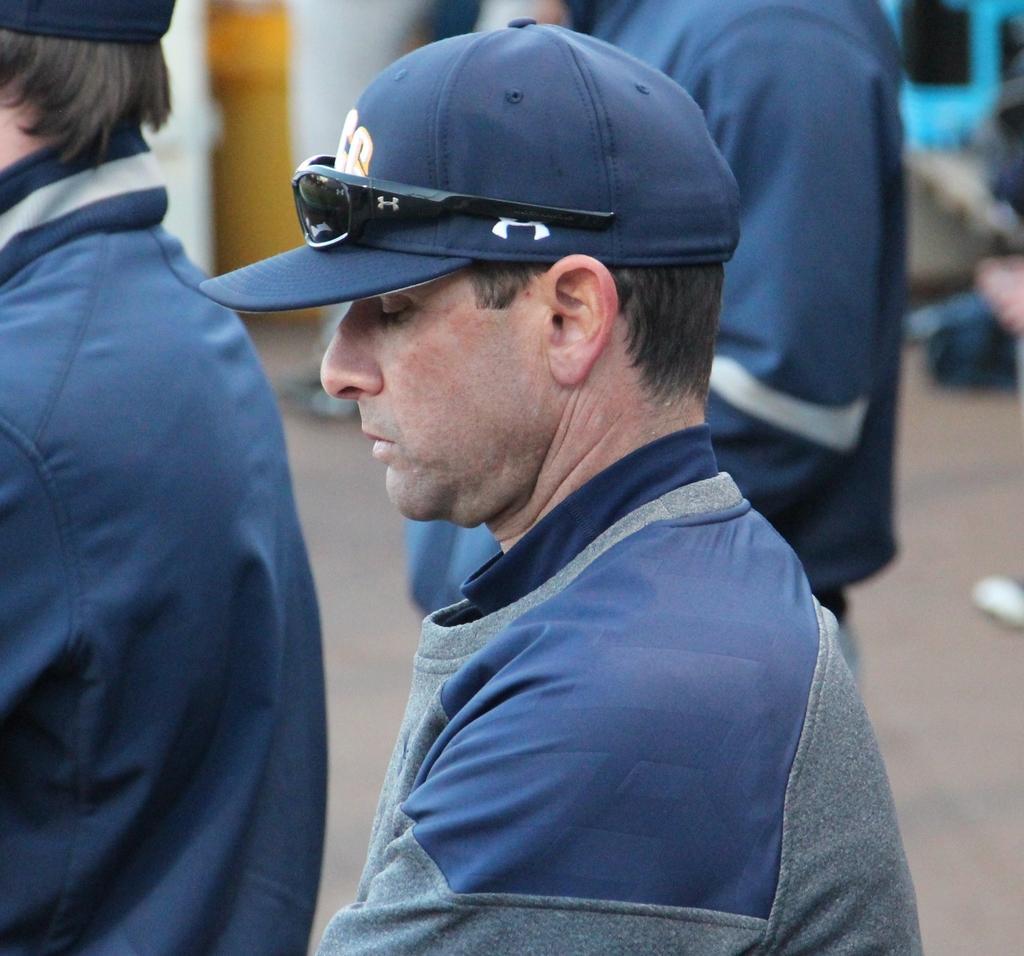Could you give a brief overview of what you see in this image? This is outdoor picture. The picture is highlighted with a man and this man wore a blue cap. He is wearing a black specks over the cap. beside this man there is one man standing over there and o the left side of the picture we can see other man standing. 